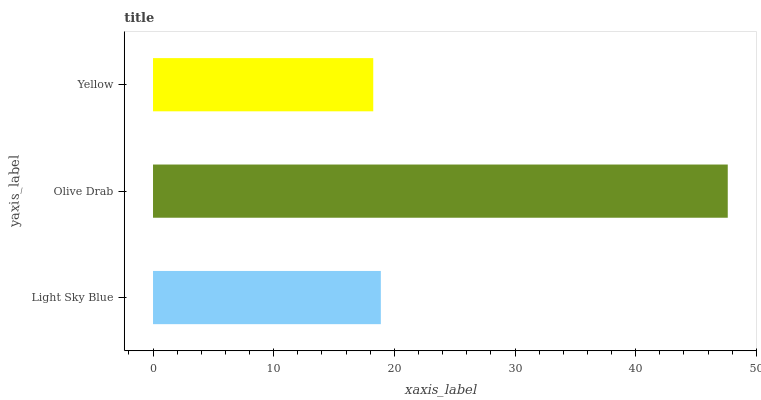Is Yellow the minimum?
Answer yes or no. Yes. Is Olive Drab the maximum?
Answer yes or no. Yes. Is Olive Drab the minimum?
Answer yes or no. No. Is Yellow the maximum?
Answer yes or no. No. Is Olive Drab greater than Yellow?
Answer yes or no. Yes. Is Yellow less than Olive Drab?
Answer yes or no. Yes. Is Yellow greater than Olive Drab?
Answer yes or no. No. Is Olive Drab less than Yellow?
Answer yes or no. No. Is Light Sky Blue the high median?
Answer yes or no. Yes. Is Light Sky Blue the low median?
Answer yes or no. Yes. Is Olive Drab the high median?
Answer yes or no. No. Is Yellow the low median?
Answer yes or no. No. 